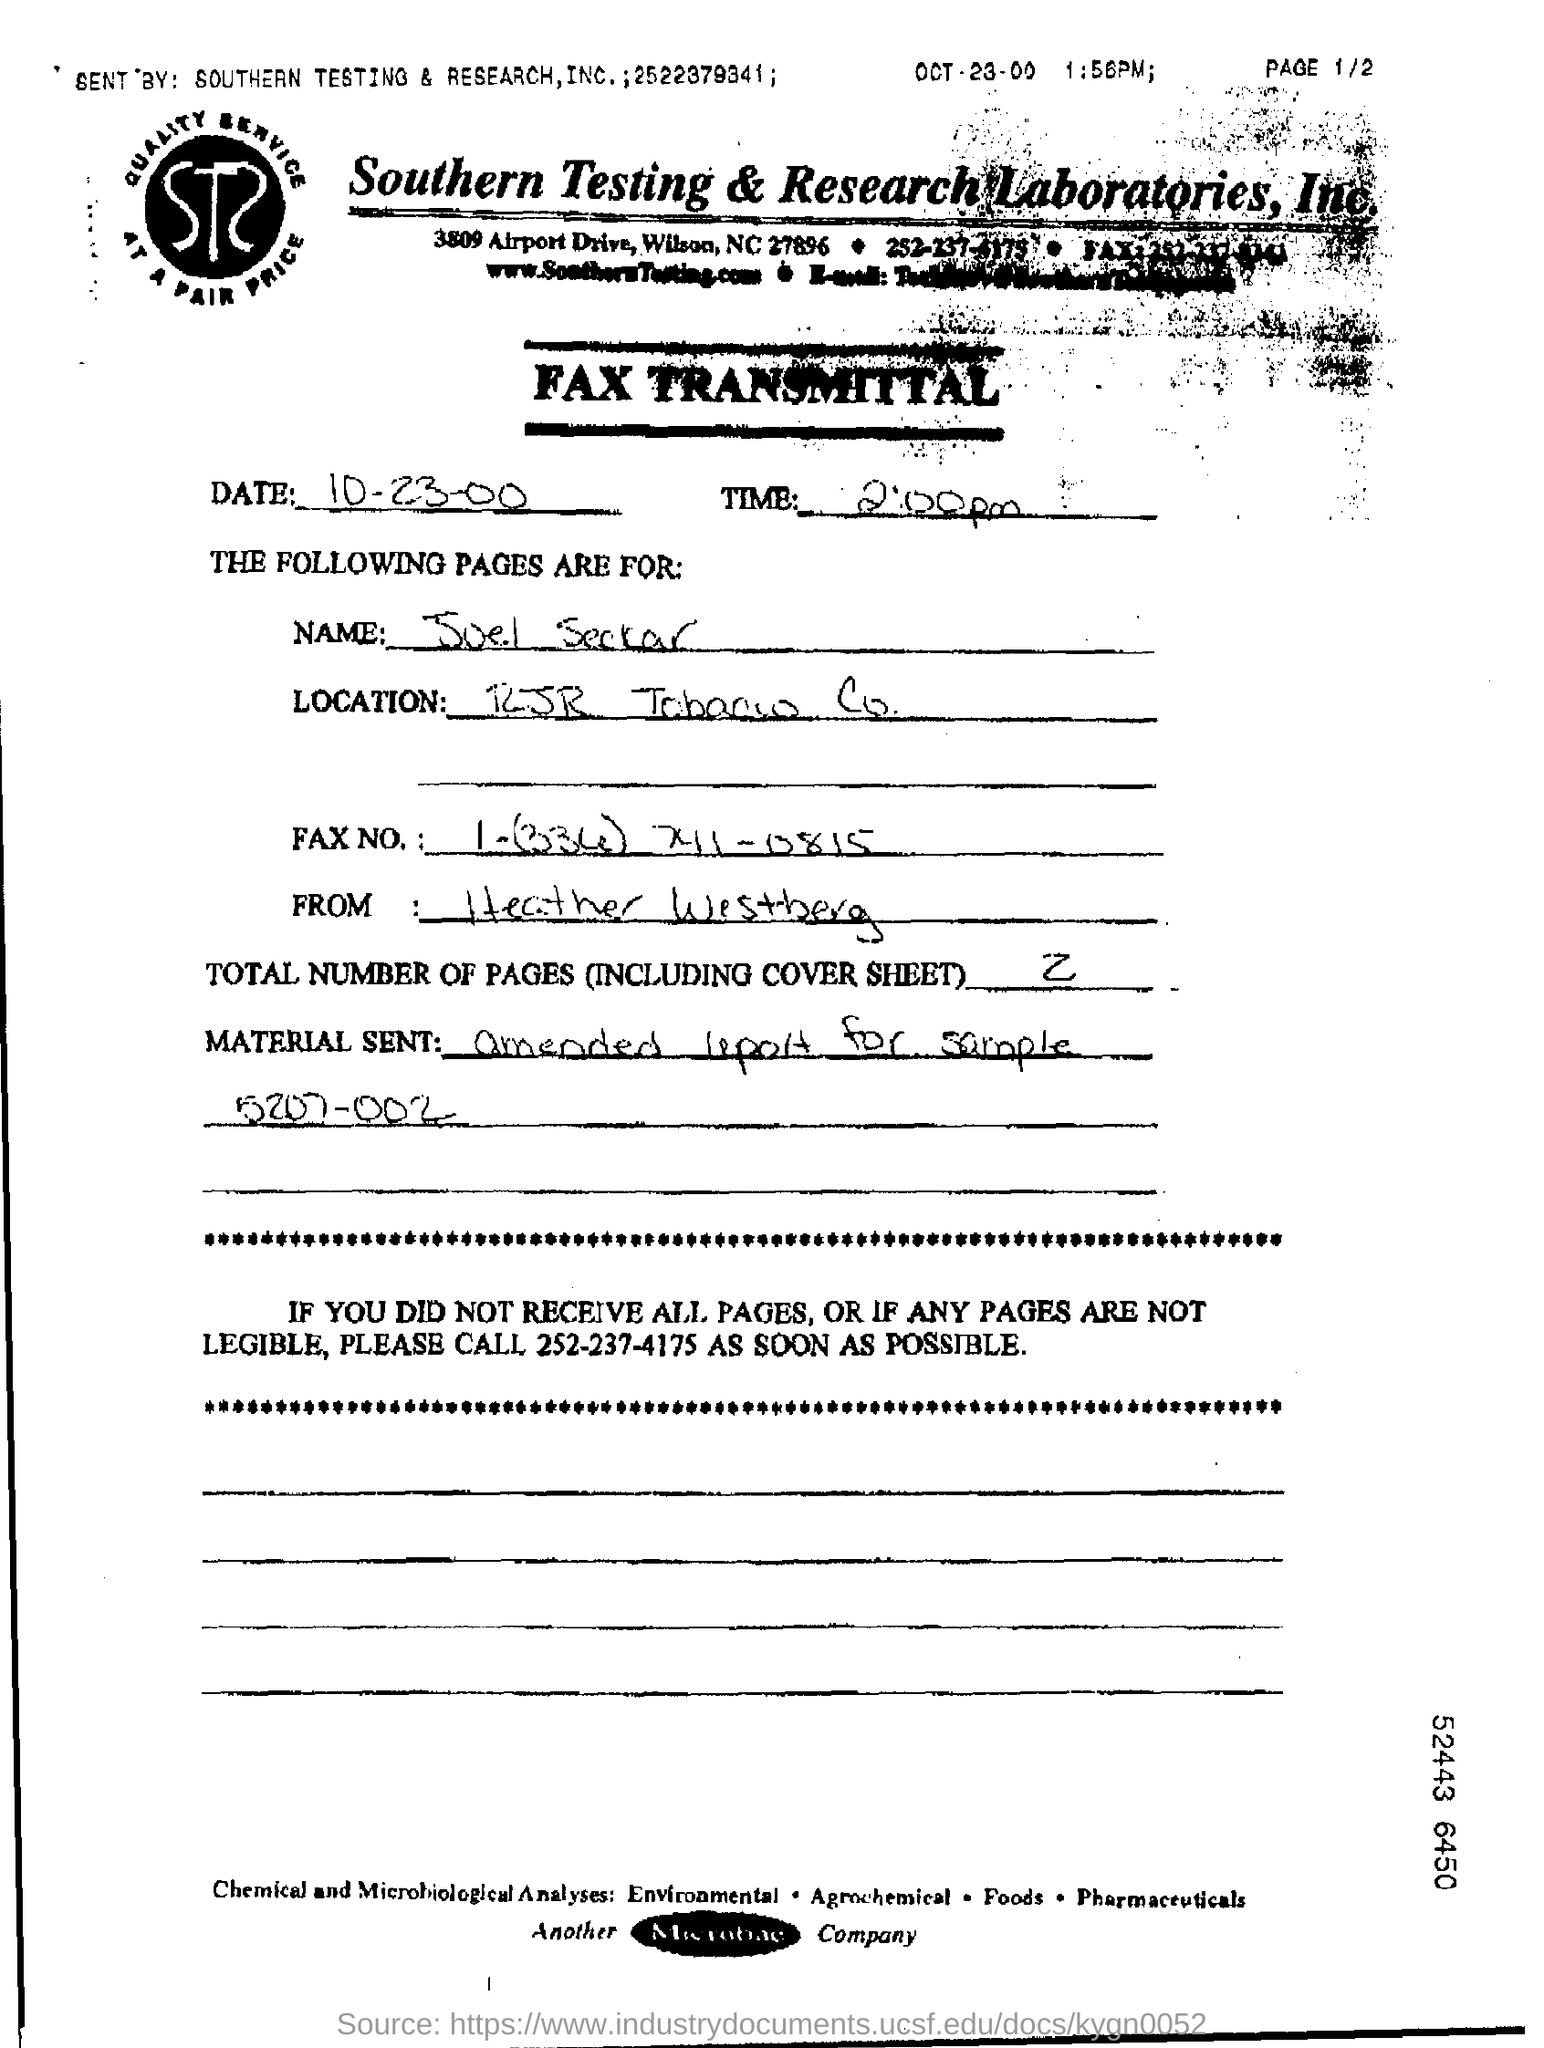What are the total number of pages (including cover sheet ) ?
Provide a succinct answer. 2. What is the material sent in the fax ?
Provide a short and direct response. Amended report for sample 5207-002. 